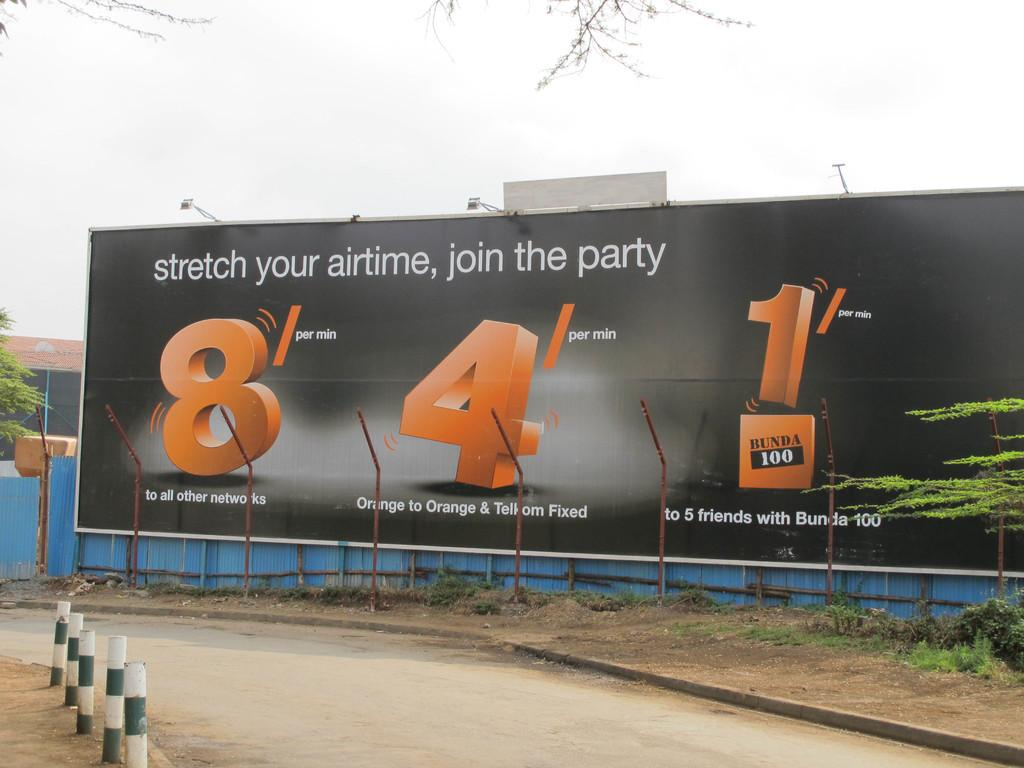What is the main object in the image? There is an advertisement board in the image. How is the advertisement board positioned? The advertisement board is attached to a fencing. What can be seen beside the road in front of the board? There are poles beside the road in front of the board. What type of vegetation is on the right side of the image? There is a plant on the right side of the image. What type of paste is being used to hold the advertisement board on the stage? There is no stage or paste present in the image; it features an advertisement board attached to a fencing. What color is the paint on the plant in the image? There is no paint on the plant in the image; it is a natural plant. 